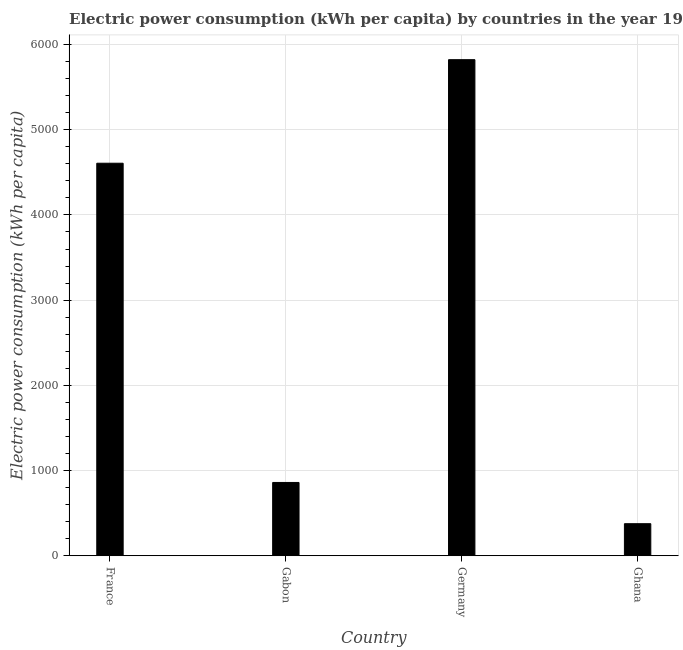Does the graph contain any zero values?
Offer a terse response. No. Does the graph contain grids?
Make the answer very short. Yes. What is the title of the graph?
Keep it short and to the point. Electric power consumption (kWh per capita) by countries in the year 1982. What is the label or title of the X-axis?
Ensure brevity in your answer.  Country. What is the label or title of the Y-axis?
Offer a very short reply. Electric power consumption (kWh per capita). What is the electric power consumption in France?
Make the answer very short. 4606.91. Across all countries, what is the maximum electric power consumption?
Provide a short and direct response. 5822.03. Across all countries, what is the minimum electric power consumption?
Offer a terse response. 376.65. In which country was the electric power consumption minimum?
Offer a very short reply. Ghana. What is the sum of the electric power consumption?
Provide a short and direct response. 1.17e+04. What is the difference between the electric power consumption in France and Gabon?
Make the answer very short. 3746.26. What is the average electric power consumption per country?
Give a very brief answer. 2916.56. What is the median electric power consumption?
Your answer should be very brief. 2733.78. In how many countries, is the electric power consumption greater than 5600 kWh per capita?
Your answer should be compact. 1. What is the ratio of the electric power consumption in Gabon to that in Germany?
Ensure brevity in your answer.  0.15. What is the difference between the highest and the second highest electric power consumption?
Make the answer very short. 1215.12. Is the sum of the electric power consumption in France and Gabon greater than the maximum electric power consumption across all countries?
Provide a succinct answer. No. What is the difference between the highest and the lowest electric power consumption?
Your answer should be very brief. 5445.38. In how many countries, is the electric power consumption greater than the average electric power consumption taken over all countries?
Your answer should be very brief. 2. Are all the bars in the graph horizontal?
Your answer should be compact. No. What is the difference between two consecutive major ticks on the Y-axis?
Your response must be concise. 1000. Are the values on the major ticks of Y-axis written in scientific E-notation?
Offer a very short reply. No. What is the Electric power consumption (kWh per capita) of France?
Your answer should be very brief. 4606.91. What is the Electric power consumption (kWh per capita) in Gabon?
Your answer should be compact. 860.64. What is the Electric power consumption (kWh per capita) in Germany?
Your answer should be compact. 5822.03. What is the Electric power consumption (kWh per capita) of Ghana?
Your answer should be very brief. 376.65. What is the difference between the Electric power consumption (kWh per capita) in France and Gabon?
Offer a terse response. 3746.26. What is the difference between the Electric power consumption (kWh per capita) in France and Germany?
Provide a short and direct response. -1215.12. What is the difference between the Electric power consumption (kWh per capita) in France and Ghana?
Offer a very short reply. 4230.26. What is the difference between the Electric power consumption (kWh per capita) in Gabon and Germany?
Keep it short and to the point. -4961.38. What is the difference between the Electric power consumption (kWh per capita) in Gabon and Ghana?
Provide a short and direct response. 483.99. What is the difference between the Electric power consumption (kWh per capita) in Germany and Ghana?
Offer a terse response. 5445.38. What is the ratio of the Electric power consumption (kWh per capita) in France to that in Gabon?
Your answer should be compact. 5.35. What is the ratio of the Electric power consumption (kWh per capita) in France to that in Germany?
Your answer should be compact. 0.79. What is the ratio of the Electric power consumption (kWh per capita) in France to that in Ghana?
Give a very brief answer. 12.23. What is the ratio of the Electric power consumption (kWh per capita) in Gabon to that in Germany?
Offer a terse response. 0.15. What is the ratio of the Electric power consumption (kWh per capita) in Gabon to that in Ghana?
Ensure brevity in your answer.  2.29. What is the ratio of the Electric power consumption (kWh per capita) in Germany to that in Ghana?
Your response must be concise. 15.46. 